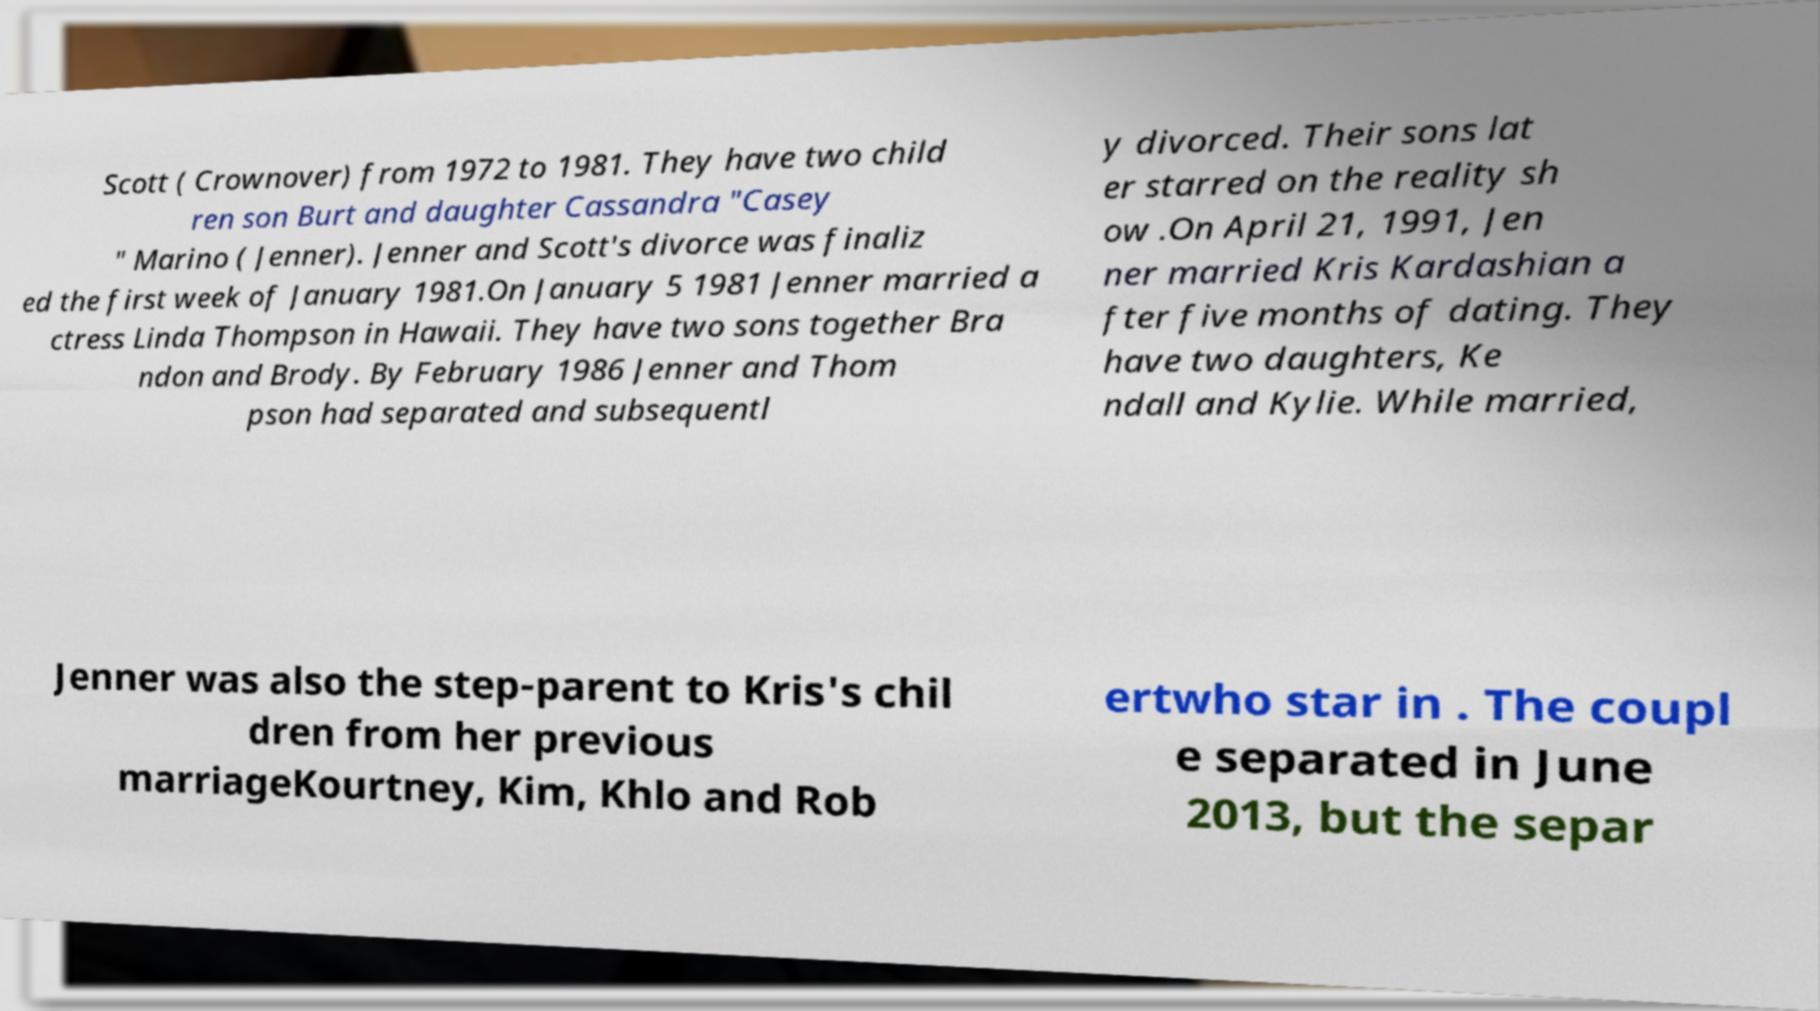Could you assist in decoding the text presented in this image and type it out clearly? Scott ( Crownover) from 1972 to 1981. They have two child ren son Burt and daughter Cassandra "Casey " Marino ( Jenner). Jenner and Scott's divorce was finaliz ed the first week of January 1981.On January 5 1981 Jenner married a ctress Linda Thompson in Hawaii. They have two sons together Bra ndon and Brody. By February 1986 Jenner and Thom pson had separated and subsequentl y divorced. Their sons lat er starred on the reality sh ow .On April 21, 1991, Jen ner married Kris Kardashian a fter five months of dating. They have two daughters, Ke ndall and Kylie. While married, Jenner was also the step-parent to Kris's chil dren from her previous marriageKourtney, Kim, Khlo and Rob ertwho star in . The coupl e separated in June 2013, but the separ 